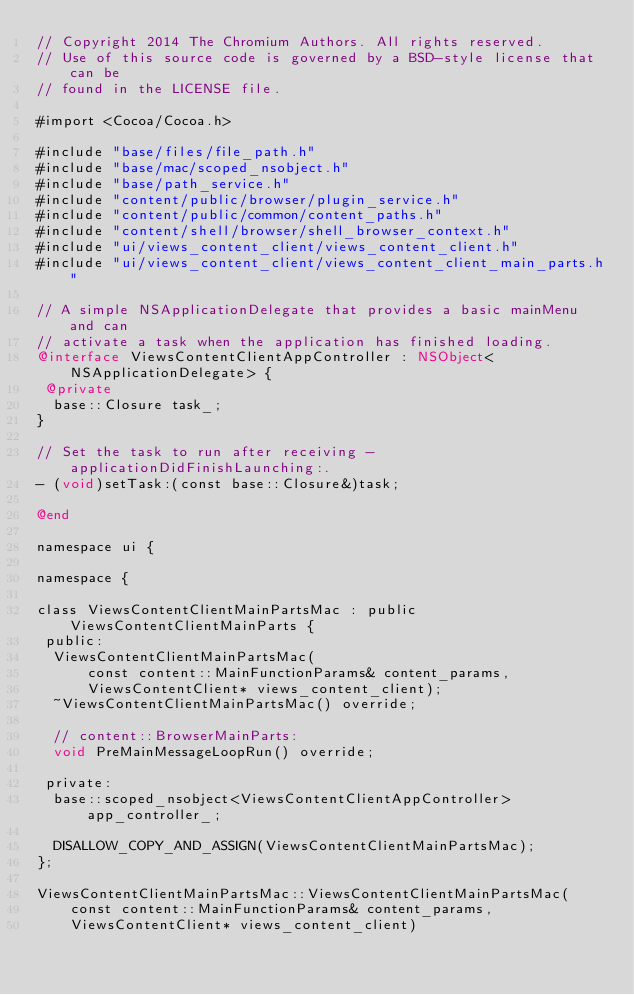Convert code to text. <code><loc_0><loc_0><loc_500><loc_500><_ObjectiveC_>// Copyright 2014 The Chromium Authors. All rights reserved.
// Use of this source code is governed by a BSD-style license that can be
// found in the LICENSE file.

#import <Cocoa/Cocoa.h>

#include "base/files/file_path.h"
#include "base/mac/scoped_nsobject.h"
#include "base/path_service.h"
#include "content/public/browser/plugin_service.h"
#include "content/public/common/content_paths.h"
#include "content/shell/browser/shell_browser_context.h"
#include "ui/views_content_client/views_content_client.h"
#include "ui/views_content_client/views_content_client_main_parts.h"

// A simple NSApplicationDelegate that provides a basic mainMenu and can
// activate a task when the application has finished loading.
@interface ViewsContentClientAppController : NSObject<NSApplicationDelegate> {
 @private
  base::Closure task_;
}

// Set the task to run after receiving -applicationDidFinishLaunching:.
- (void)setTask:(const base::Closure&)task;

@end

namespace ui {

namespace {

class ViewsContentClientMainPartsMac : public ViewsContentClientMainParts {
 public:
  ViewsContentClientMainPartsMac(
      const content::MainFunctionParams& content_params,
      ViewsContentClient* views_content_client);
  ~ViewsContentClientMainPartsMac() override;

  // content::BrowserMainParts:
  void PreMainMessageLoopRun() override;

 private:
  base::scoped_nsobject<ViewsContentClientAppController> app_controller_;

  DISALLOW_COPY_AND_ASSIGN(ViewsContentClientMainPartsMac);
};

ViewsContentClientMainPartsMac::ViewsContentClientMainPartsMac(
    const content::MainFunctionParams& content_params,
    ViewsContentClient* views_content_client)</code> 